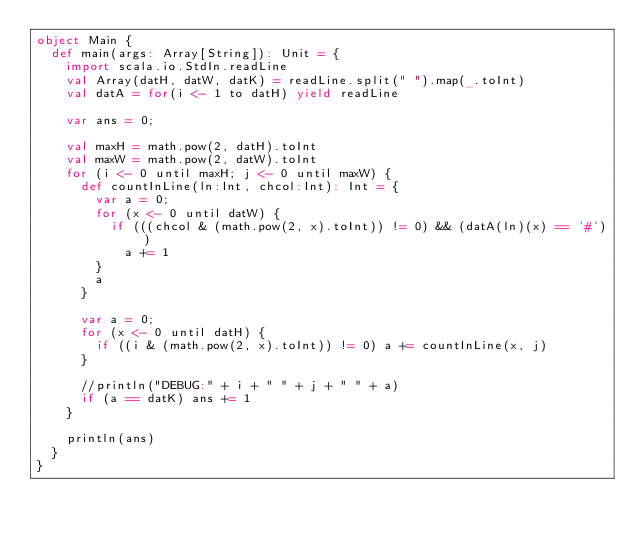<code> <loc_0><loc_0><loc_500><loc_500><_Scala_>object Main {
  def main(args: Array[String]): Unit = {
    import scala.io.StdIn.readLine
    val Array(datH, datW, datK) = readLine.split(" ").map(_.toInt)
    val datA = for(i <- 1 to datH) yield readLine

    var ans = 0;

    val maxH = math.pow(2, datH).toInt
    val maxW = math.pow(2, datW).toInt
    for (i <- 0 until maxH; j <- 0 until maxW) {
      def countInLine(ln:Int, chcol:Int): Int = {
        var a = 0;
        for (x <- 0 until datW) {
          if (((chcol & (math.pow(2, x).toInt)) != 0) && (datA(ln)(x) == '#'))
            a += 1
        }
        a
      }

      var a = 0;
      for (x <- 0 until datH) {
        if ((i & (math.pow(2, x).toInt)) != 0) a += countInLine(x, j)
      }

      //println("DEBUG:" + i + " " + j + " " + a)
      if (a == datK) ans += 1
    }

    println(ans)
  }
}
</code> 